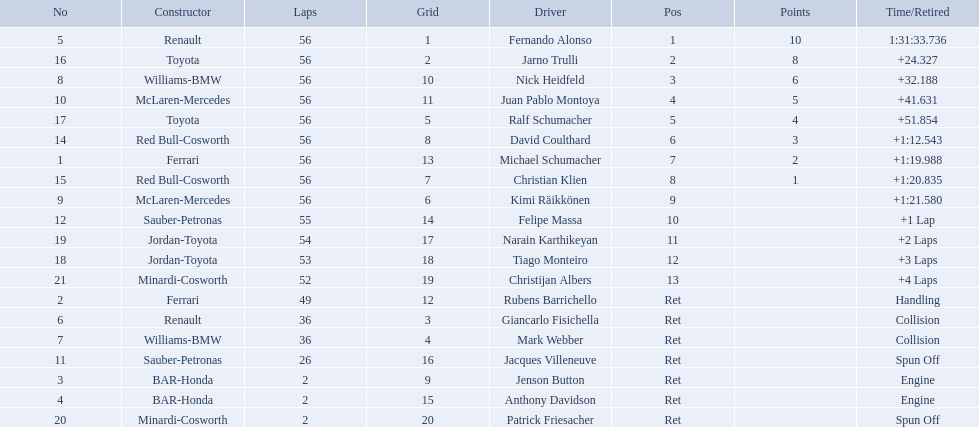Who raced during the 2005 malaysian grand prix? Fernando Alonso, Jarno Trulli, Nick Heidfeld, Juan Pablo Montoya, Ralf Schumacher, David Coulthard, Michael Schumacher, Christian Klien, Kimi Räikkönen, Felipe Massa, Narain Karthikeyan, Tiago Monteiro, Christijan Albers, Rubens Barrichello, Giancarlo Fisichella, Mark Webber, Jacques Villeneuve, Jenson Button, Anthony Davidson, Patrick Friesacher. What were their finishing times? 1:31:33.736, +24.327, +32.188, +41.631, +51.854, +1:12.543, +1:19.988, +1:20.835, +1:21.580, +1 Lap, +2 Laps, +3 Laps, +4 Laps, Handling, Collision, Collision, Spun Off, Engine, Engine, Spun Off. What was fernando alonso's finishing time? 1:31:33.736. 